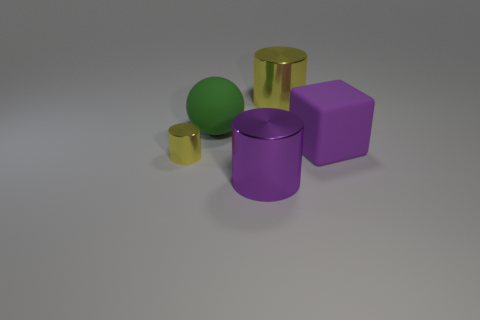There is a large block that is on the right side of the large cylinder that is right of the large shiny cylinder that is in front of the large purple rubber block; what is its color?
Make the answer very short. Purple. There is a large purple thing that is the same shape as the large yellow metal object; what is its material?
Provide a succinct answer. Metal. The small metallic cylinder has what color?
Provide a short and direct response. Yellow. Is the color of the matte cube the same as the large matte sphere?
Give a very brief answer. No. How many matte objects are purple blocks or balls?
Offer a very short reply. 2. There is a purple object that is in front of the yellow object that is left of the green matte object; is there a big purple object that is behind it?
Ensure brevity in your answer.  Yes. What is the size of the other yellow cylinder that is the same material as the small cylinder?
Keep it short and to the point. Large. Are there any tiny yellow objects behind the tiny metallic thing?
Your answer should be compact. No. There is a large rubber object that is to the right of the large green matte object; is there a yellow cylinder in front of it?
Offer a very short reply. Yes. There is a yellow shiny cylinder right of the green rubber ball; does it have the same size as the yellow object left of the matte ball?
Ensure brevity in your answer.  No. 